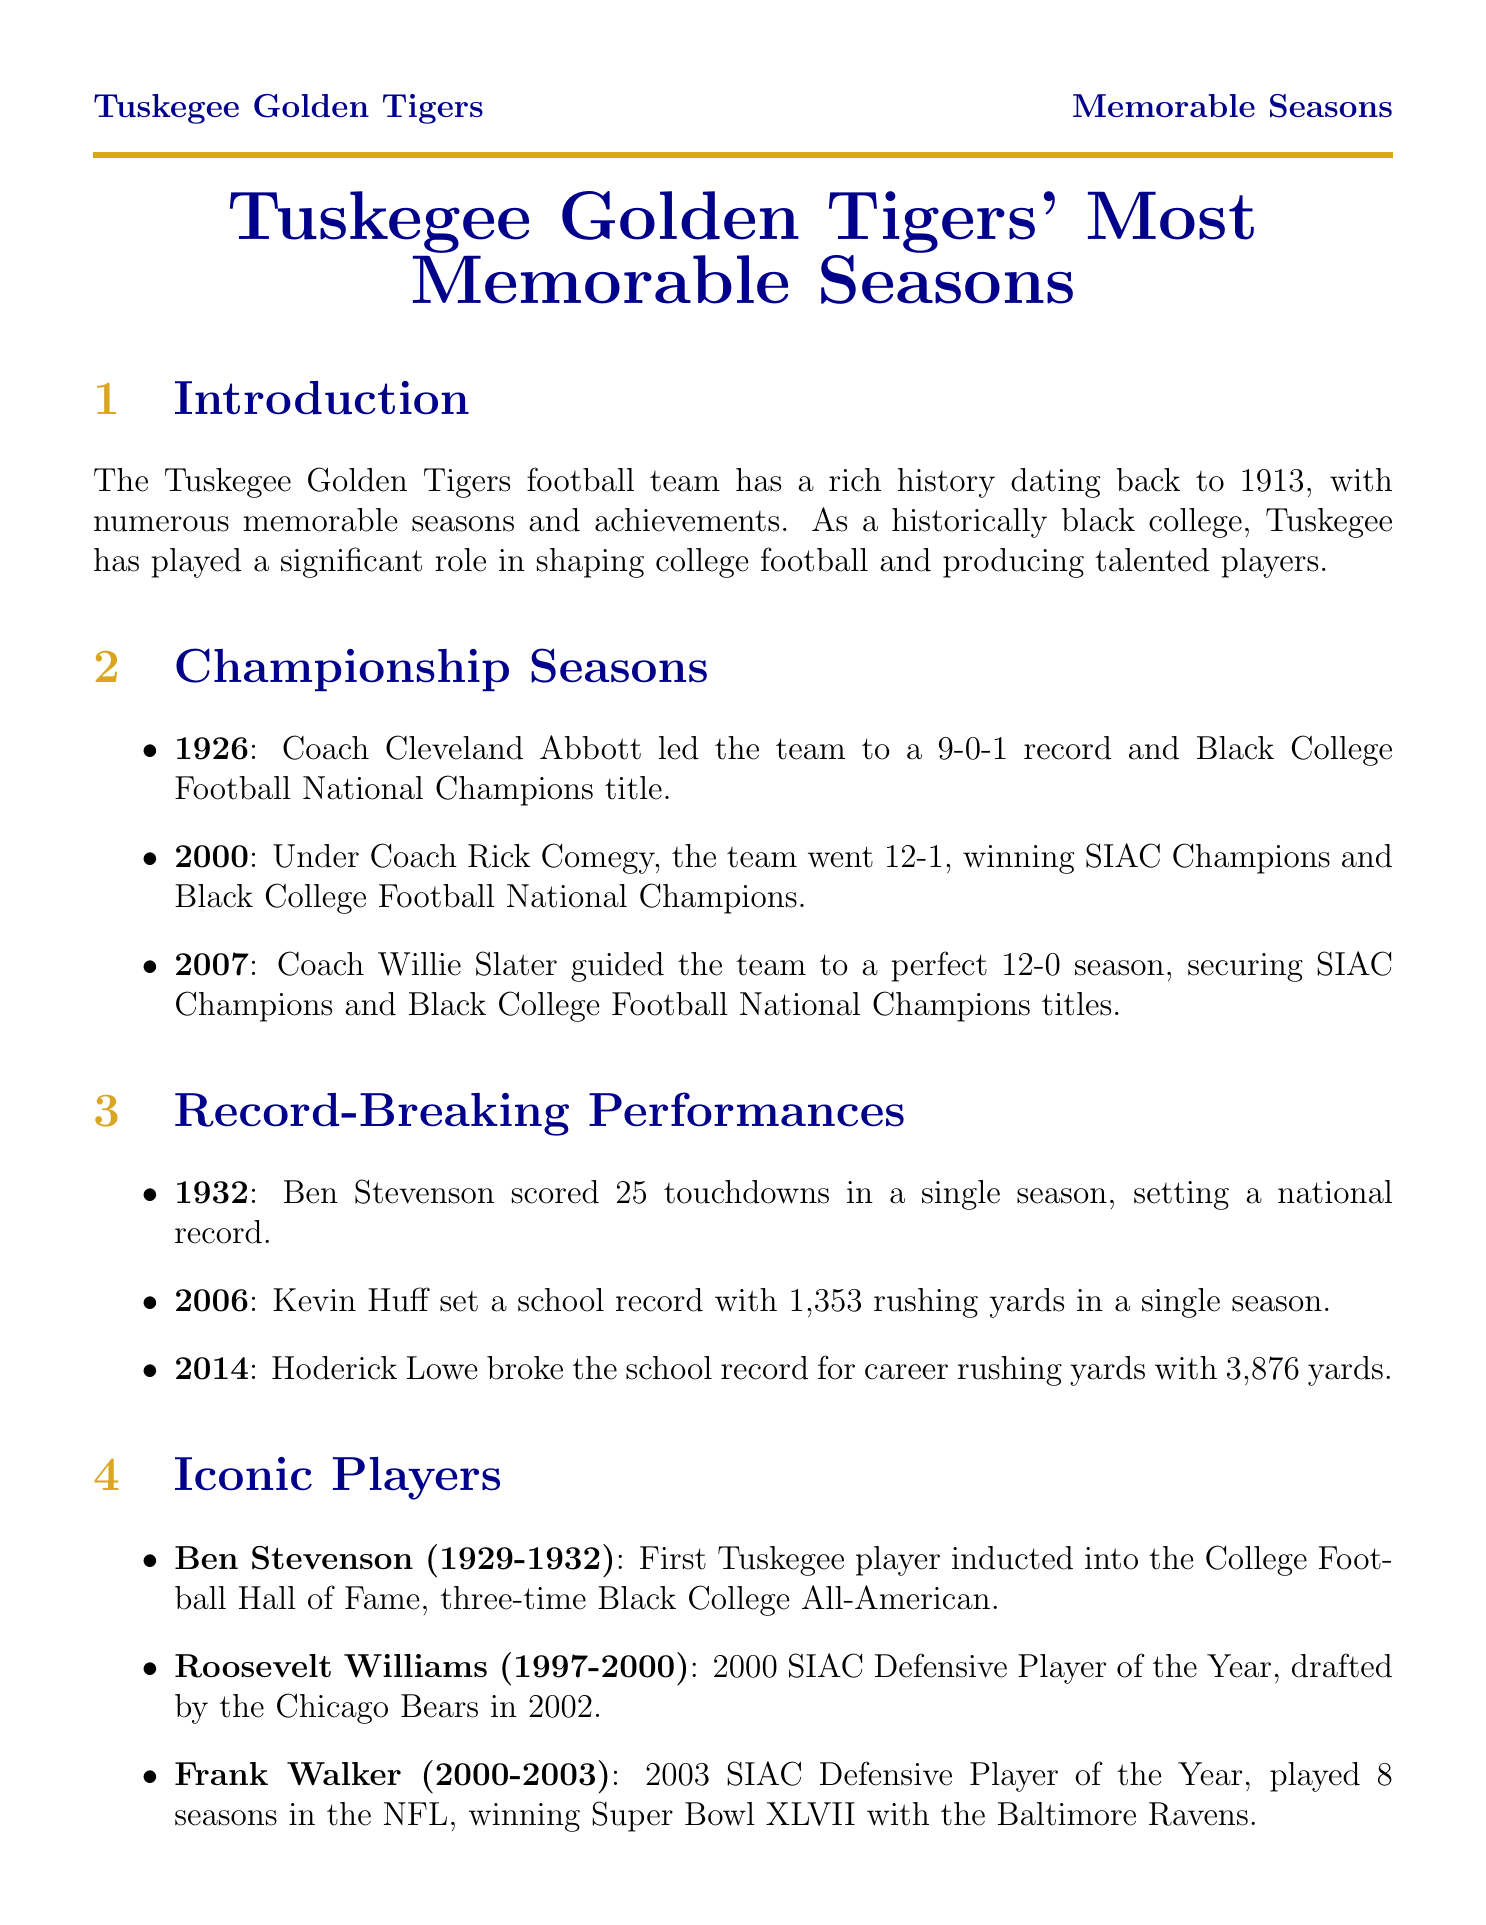What year did the Tuskegee Golden Tigers win the Black College Football National Championship under Coach Cleveland Abbott? The document states that in 1926, under Coach Cleveland Abbott, the team was Black College Football National Champions.
Answer: 1926 Who was the first Tuskegee player inducted into the College Football Hall of Fame? The document identifies Ben Stevenson as the first Tuskegee player inducted into the College Football Hall of Fame.
Answer: Ben Stevenson How many touchdowns did Ben Stevenson score in a single season to set a national record? According to the document, Ben Stevenson scored 25 touchdowns in the 1932 season, setting a national record.
Answer: 25 What is the significance of the game played in 1922 against Alabama State? The document highlights that the game in 1922 was the First Turkey Day Classic, which began one of the oldest HBCU rivalries.
Answer: First Turkey Day Classic How many SIAC championships did Cleveland Abbott win during his coaching career? The document states that Cleveland Abbott won 12 SIAC championships during his coaching tenure.
Answer: 12 